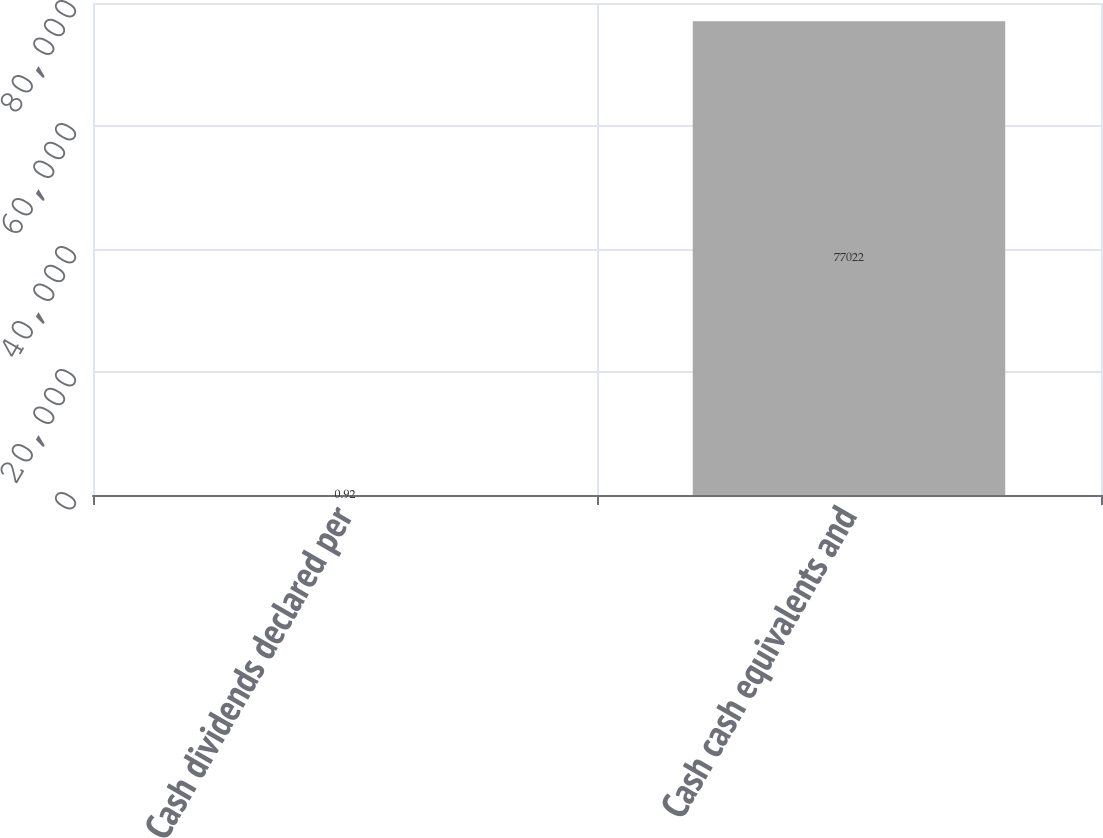<chart> <loc_0><loc_0><loc_500><loc_500><bar_chart><fcel>Cash dividends declared per<fcel>Cash cash equivalents and<nl><fcel>0.92<fcel>77022<nl></chart> 